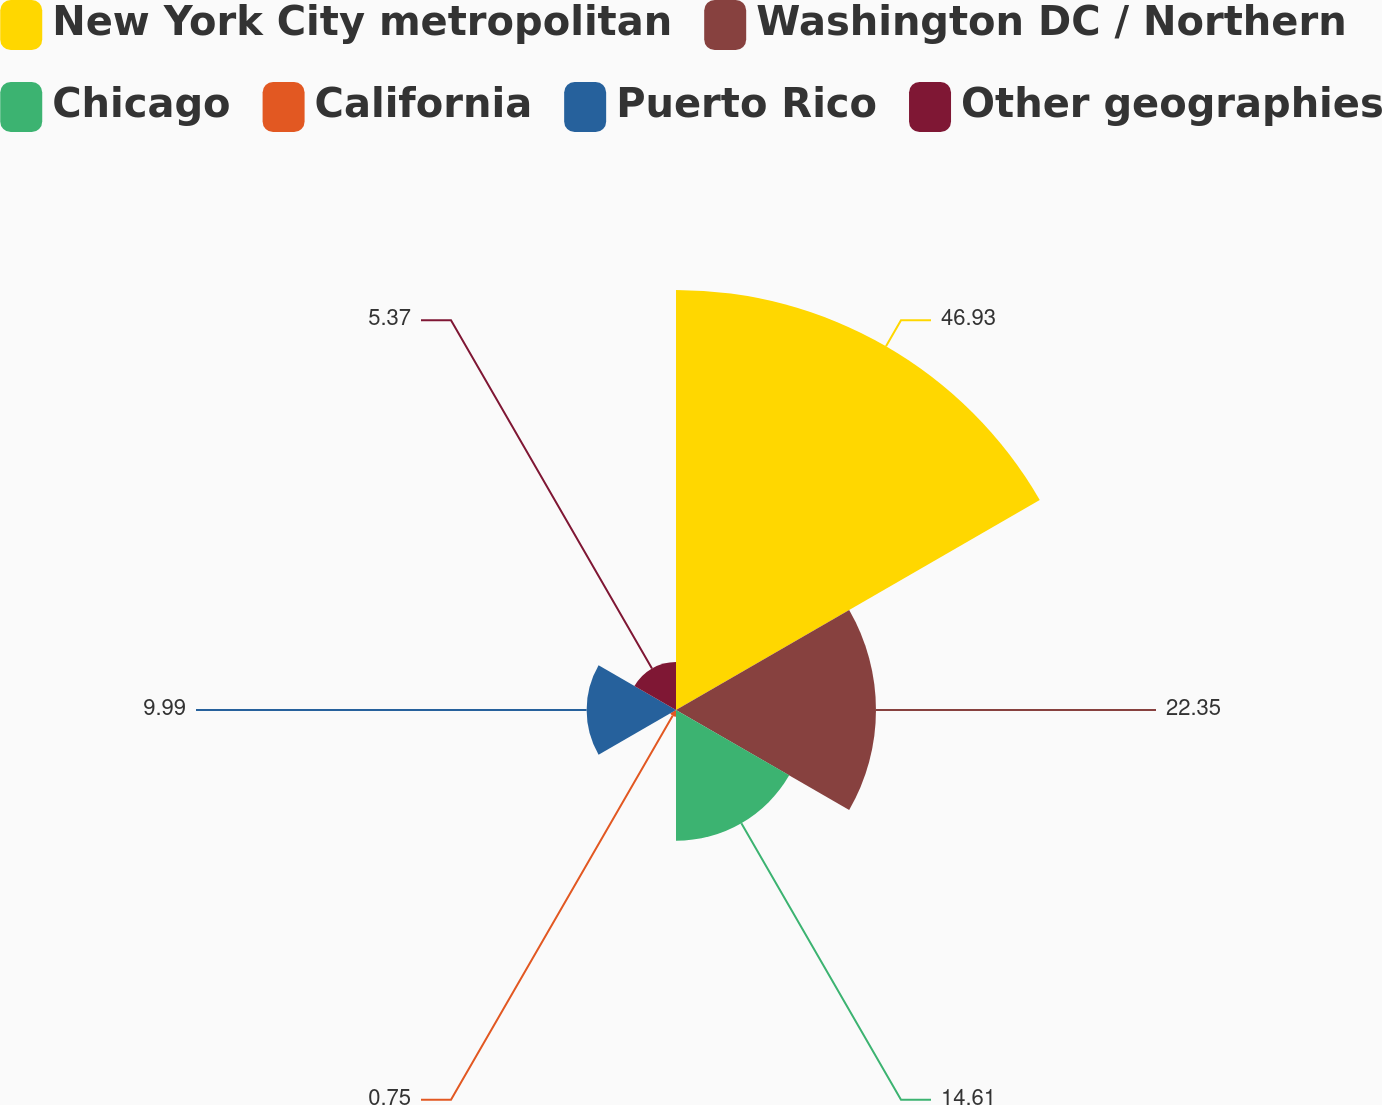<chart> <loc_0><loc_0><loc_500><loc_500><pie_chart><fcel>New York City metropolitan<fcel>Washington DC / Northern<fcel>Chicago<fcel>California<fcel>Puerto Rico<fcel>Other geographies<nl><fcel>46.94%<fcel>22.35%<fcel>14.61%<fcel>0.75%<fcel>9.99%<fcel>5.37%<nl></chart> 